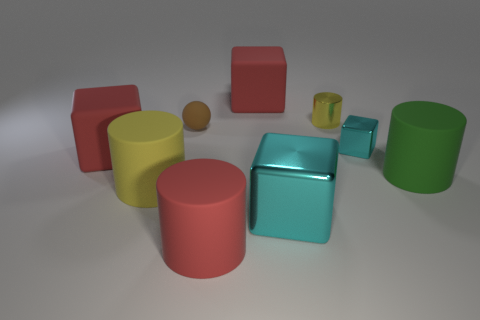Subtract all small cyan shiny blocks. How many blocks are left? 3 Subtract all red cubes. How many cubes are left? 2 Subtract 1 blocks. How many blocks are left? 3 Subtract all purple blocks. How many yellow cylinders are left? 2 Add 1 gray cylinders. How many objects exist? 10 Subtract all balls. How many objects are left? 8 Subtract all cyan cylinders. Subtract all cyan cubes. How many cylinders are left? 4 Subtract all big yellow matte objects. Subtract all large green objects. How many objects are left? 7 Add 2 green rubber objects. How many green rubber objects are left? 3 Add 3 red metallic objects. How many red metallic objects exist? 3 